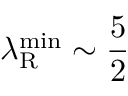<formula> <loc_0><loc_0><loc_500><loc_500>\lambda _ { R } ^ { \min } \sim \frac { 5 } { 2 }</formula> 